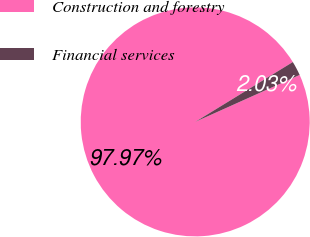<chart> <loc_0><loc_0><loc_500><loc_500><pie_chart><fcel>Construction and forestry<fcel>Financial services<nl><fcel>97.97%<fcel>2.03%<nl></chart> 